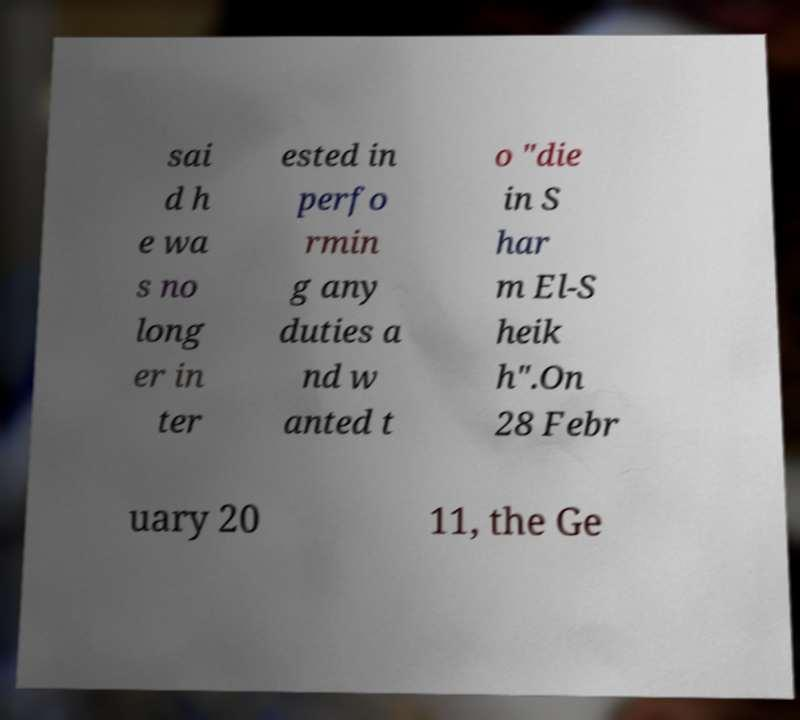What messages or text are displayed in this image? I need them in a readable, typed format. sai d h e wa s no long er in ter ested in perfo rmin g any duties a nd w anted t o "die in S har m El-S heik h".On 28 Febr uary 20 11, the Ge 